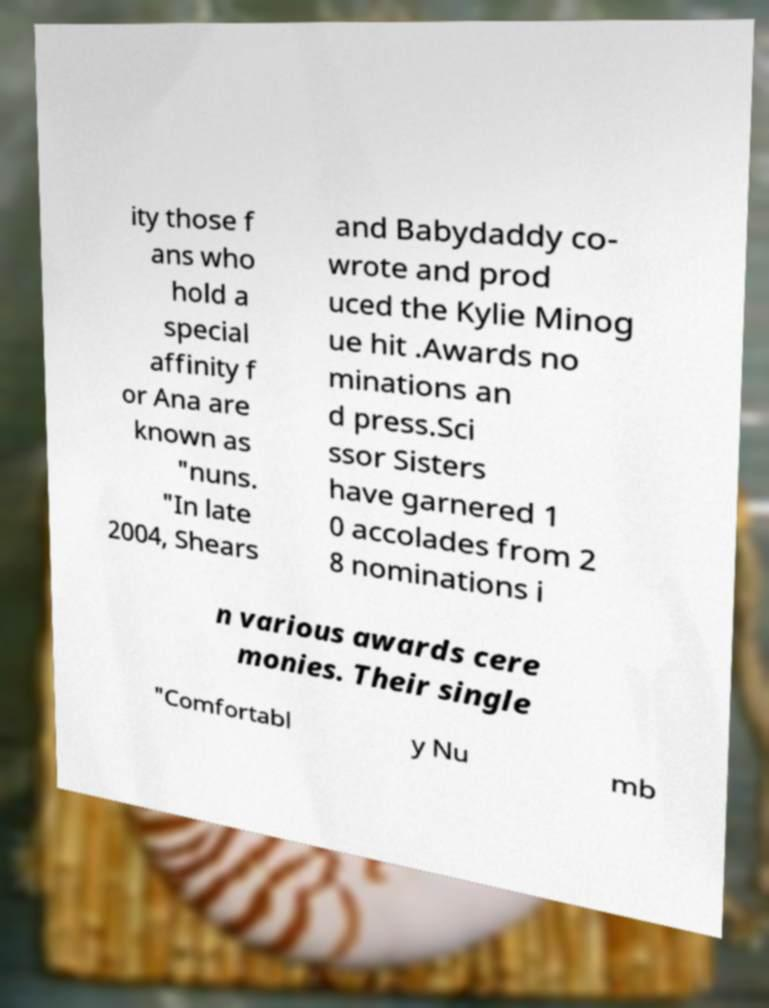For documentation purposes, I need the text within this image transcribed. Could you provide that? ity those f ans who hold a special affinity f or Ana are known as "nuns. "In late 2004, Shears and Babydaddy co- wrote and prod uced the Kylie Minog ue hit .Awards no minations an d press.Sci ssor Sisters have garnered 1 0 accolades from 2 8 nominations i n various awards cere monies. Their single "Comfortabl y Nu mb 